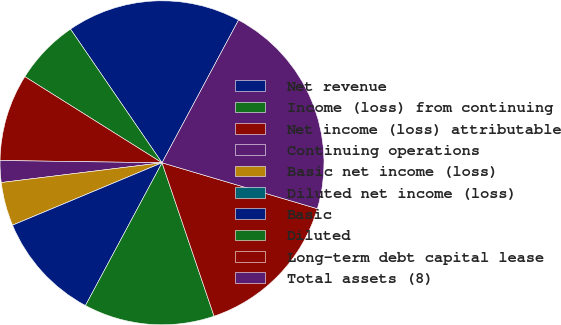Convert chart. <chart><loc_0><loc_0><loc_500><loc_500><pie_chart><fcel>Net revenue<fcel>Income (loss) from continuing<fcel>Net income (loss) attributable<fcel>Continuing operations<fcel>Basic net income (loss)<fcel>Diluted net income (loss)<fcel>Basic<fcel>Diluted<fcel>Long-term debt capital lease<fcel>Total assets (8)<nl><fcel>17.39%<fcel>6.52%<fcel>8.7%<fcel>2.17%<fcel>4.35%<fcel>0.0%<fcel>10.87%<fcel>13.04%<fcel>15.22%<fcel>21.74%<nl></chart> 